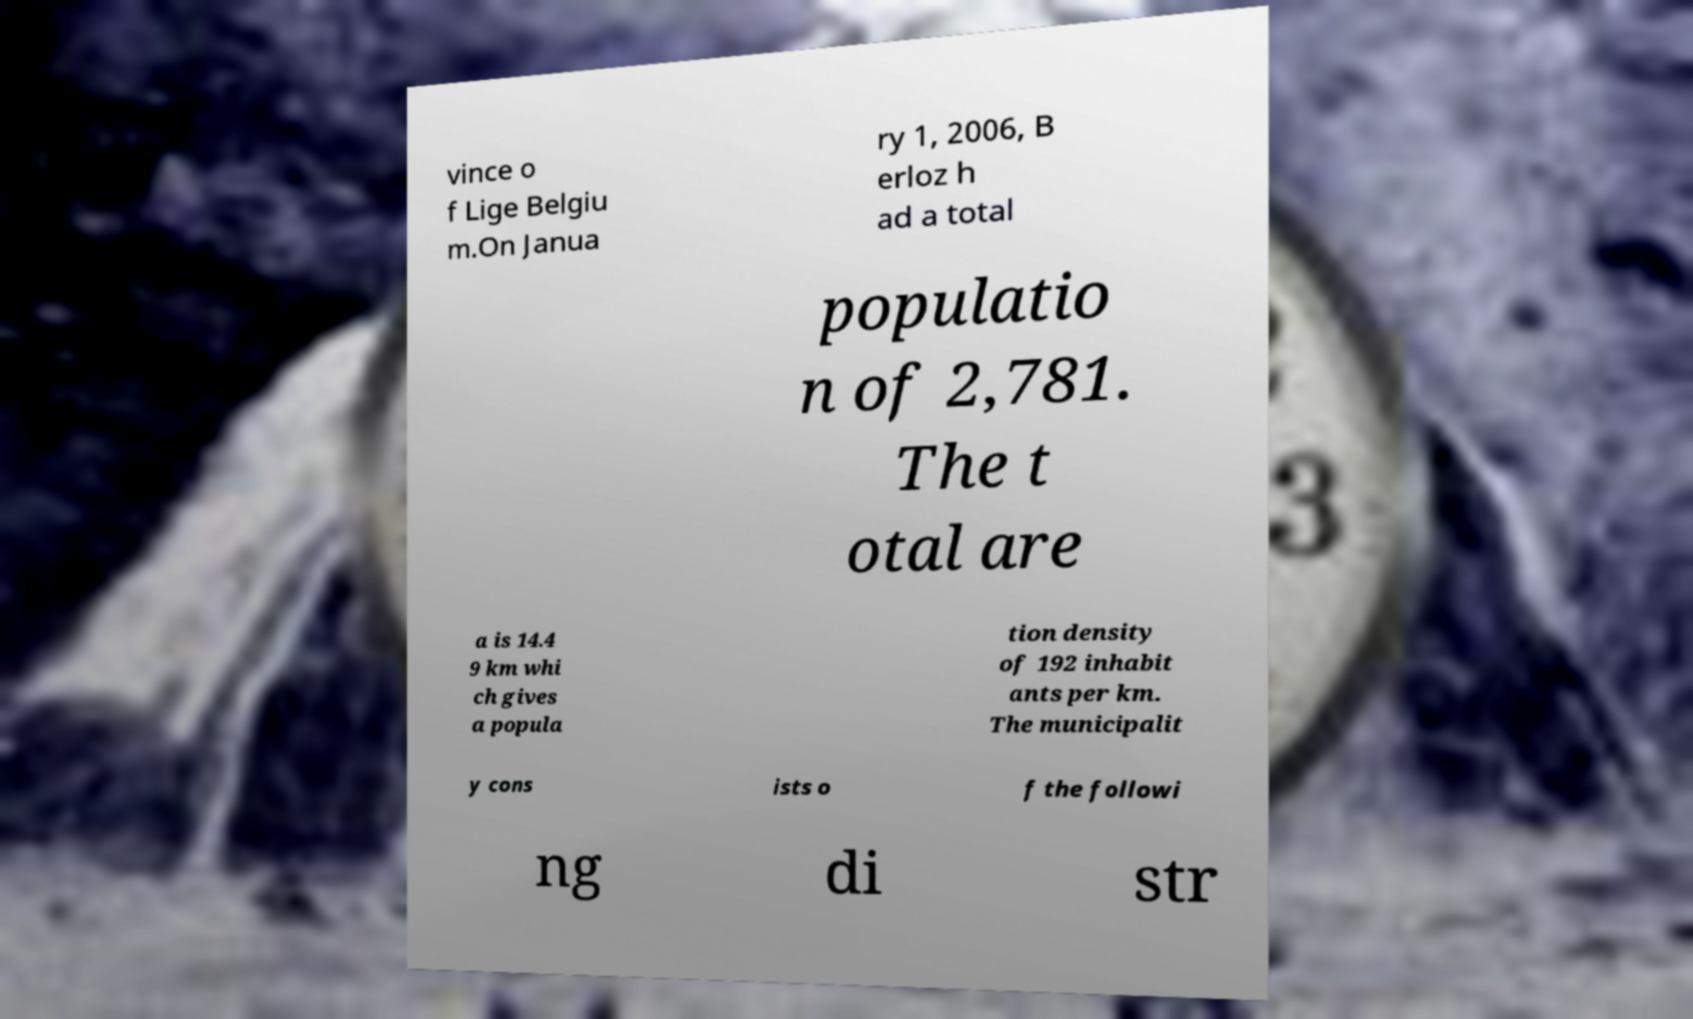Can you accurately transcribe the text from the provided image for me? vince o f Lige Belgiu m.On Janua ry 1, 2006, B erloz h ad a total populatio n of 2,781. The t otal are a is 14.4 9 km whi ch gives a popula tion density of 192 inhabit ants per km. The municipalit y cons ists o f the followi ng di str 